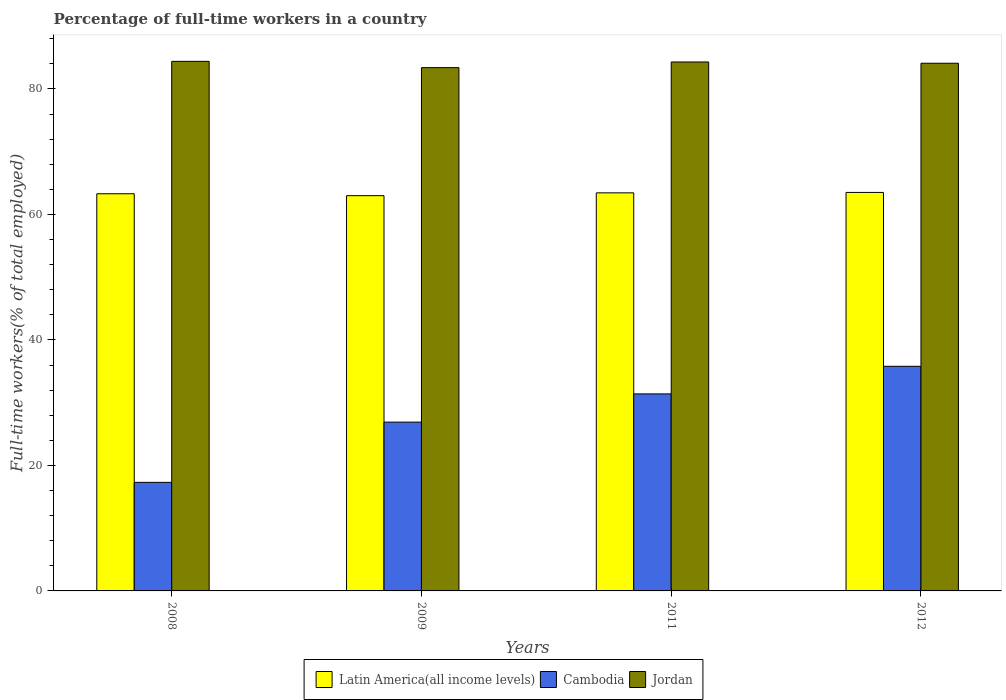How many different coloured bars are there?
Provide a short and direct response. 3. How many groups of bars are there?
Your response must be concise. 4. Are the number of bars on each tick of the X-axis equal?
Your answer should be compact. Yes. What is the percentage of full-time workers in Cambodia in 2009?
Your response must be concise. 26.9. Across all years, what is the maximum percentage of full-time workers in Cambodia?
Your answer should be compact. 35.8. Across all years, what is the minimum percentage of full-time workers in Cambodia?
Keep it short and to the point. 17.3. In which year was the percentage of full-time workers in Cambodia maximum?
Give a very brief answer. 2012. What is the total percentage of full-time workers in Jordan in the graph?
Provide a short and direct response. 336.2. What is the difference between the percentage of full-time workers in Latin America(all income levels) in 2008 and that in 2011?
Give a very brief answer. -0.14. What is the difference between the percentage of full-time workers in Cambodia in 2008 and the percentage of full-time workers in Jordan in 2012?
Your answer should be compact. -66.8. What is the average percentage of full-time workers in Cambodia per year?
Make the answer very short. 27.85. In the year 2009, what is the difference between the percentage of full-time workers in Cambodia and percentage of full-time workers in Latin America(all income levels)?
Make the answer very short. -36.09. In how many years, is the percentage of full-time workers in Jordan greater than 8 %?
Give a very brief answer. 4. What is the ratio of the percentage of full-time workers in Jordan in 2008 to that in 2009?
Your response must be concise. 1.01. Is the percentage of full-time workers in Jordan in 2008 less than that in 2009?
Your answer should be compact. No. What is the difference between the highest and the second highest percentage of full-time workers in Latin America(all income levels)?
Make the answer very short. 0.07. What is the difference between the highest and the lowest percentage of full-time workers in Cambodia?
Keep it short and to the point. 18.5. In how many years, is the percentage of full-time workers in Latin America(all income levels) greater than the average percentage of full-time workers in Latin America(all income levels) taken over all years?
Offer a very short reply. 2. Is the sum of the percentage of full-time workers in Jordan in 2009 and 2011 greater than the maximum percentage of full-time workers in Cambodia across all years?
Make the answer very short. Yes. What does the 1st bar from the left in 2012 represents?
Provide a short and direct response. Latin America(all income levels). What does the 1st bar from the right in 2008 represents?
Offer a very short reply. Jordan. How many bars are there?
Your answer should be compact. 12. Are all the bars in the graph horizontal?
Your answer should be compact. No. How many years are there in the graph?
Make the answer very short. 4. What is the difference between two consecutive major ticks on the Y-axis?
Your answer should be compact. 20. Are the values on the major ticks of Y-axis written in scientific E-notation?
Your answer should be very brief. No. Does the graph contain any zero values?
Offer a very short reply. No. Does the graph contain grids?
Provide a short and direct response. No. How many legend labels are there?
Provide a succinct answer. 3. What is the title of the graph?
Give a very brief answer. Percentage of full-time workers in a country. Does "Papua New Guinea" appear as one of the legend labels in the graph?
Keep it short and to the point. No. What is the label or title of the X-axis?
Offer a terse response. Years. What is the label or title of the Y-axis?
Provide a short and direct response. Full-time workers(% of total employed). What is the Full-time workers(% of total employed) of Latin America(all income levels) in 2008?
Offer a very short reply. 63.3. What is the Full-time workers(% of total employed) in Cambodia in 2008?
Your answer should be compact. 17.3. What is the Full-time workers(% of total employed) of Jordan in 2008?
Your response must be concise. 84.4. What is the Full-time workers(% of total employed) of Latin America(all income levels) in 2009?
Your response must be concise. 62.99. What is the Full-time workers(% of total employed) of Cambodia in 2009?
Ensure brevity in your answer.  26.9. What is the Full-time workers(% of total employed) in Jordan in 2009?
Provide a succinct answer. 83.4. What is the Full-time workers(% of total employed) of Latin America(all income levels) in 2011?
Ensure brevity in your answer.  63.44. What is the Full-time workers(% of total employed) in Cambodia in 2011?
Offer a terse response. 31.4. What is the Full-time workers(% of total employed) of Jordan in 2011?
Provide a short and direct response. 84.3. What is the Full-time workers(% of total employed) of Latin America(all income levels) in 2012?
Provide a succinct answer. 63.51. What is the Full-time workers(% of total employed) in Cambodia in 2012?
Offer a terse response. 35.8. What is the Full-time workers(% of total employed) in Jordan in 2012?
Provide a succinct answer. 84.1. Across all years, what is the maximum Full-time workers(% of total employed) in Latin America(all income levels)?
Give a very brief answer. 63.51. Across all years, what is the maximum Full-time workers(% of total employed) of Cambodia?
Your response must be concise. 35.8. Across all years, what is the maximum Full-time workers(% of total employed) in Jordan?
Make the answer very short. 84.4. Across all years, what is the minimum Full-time workers(% of total employed) in Latin America(all income levels)?
Offer a terse response. 62.99. Across all years, what is the minimum Full-time workers(% of total employed) of Cambodia?
Your answer should be compact. 17.3. Across all years, what is the minimum Full-time workers(% of total employed) in Jordan?
Your response must be concise. 83.4. What is the total Full-time workers(% of total employed) of Latin America(all income levels) in the graph?
Keep it short and to the point. 253.24. What is the total Full-time workers(% of total employed) in Cambodia in the graph?
Make the answer very short. 111.4. What is the total Full-time workers(% of total employed) in Jordan in the graph?
Make the answer very short. 336.2. What is the difference between the Full-time workers(% of total employed) in Latin America(all income levels) in 2008 and that in 2009?
Your answer should be compact. 0.3. What is the difference between the Full-time workers(% of total employed) in Jordan in 2008 and that in 2009?
Make the answer very short. 1. What is the difference between the Full-time workers(% of total employed) in Latin America(all income levels) in 2008 and that in 2011?
Your response must be concise. -0.14. What is the difference between the Full-time workers(% of total employed) of Cambodia in 2008 and that in 2011?
Keep it short and to the point. -14.1. What is the difference between the Full-time workers(% of total employed) of Jordan in 2008 and that in 2011?
Your answer should be compact. 0.1. What is the difference between the Full-time workers(% of total employed) in Latin America(all income levels) in 2008 and that in 2012?
Ensure brevity in your answer.  -0.21. What is the difference between the Full-time workers(% of total employed) in Cambodia in 2008 and that in 2012?
Provide a short and direct response. -18.5. What is the difference between the Full-time workers(% of total employed) in Latin America(all income levels) in 2009 and that in 2011?
Make the answer very short. -0.45. What is the difference between the Full-time workers(% of total employed) in Cambodia in 2009 and that in 2011?
Make the answer very short. -4.5. What is the difference between the Full-time workers(% of total employed) in Jordan in 2009 and that in 2011?
Your answer should be compact. -0.9. What is the difference between the Full-time workers(% of total employed) of Latin America(all income levels) in 2009 and that in 2012?
Make the answer very short. -0.52. What is the difference between the Full-time workers(% of total employed) of Cambodia in 2009 and that in 2012?
Ensure brevity in your answer.  -8.9. What is the difference between the Full-time workers(% of total employed) of Latin America(all income levels) in 2011 and that in 2012?
Give a very brief answer. -0.07. What is the difference between the Full-time workers(% of total employed) of Latin America(all income levels) in 2008 and the Full-time workers(% of total employed) of Cambodia in 2009?
Give a very brief answer. 36.4. What is the difference between the Full-time workers(% of total employed) in Latin America(all income levels) in 2008 and the Full-time workers(% of total employed) in Jordan in 2009?
Make the answer very short. -20.1. What is the difference between the Full-time workers(% of total employed) of Cambodia in 2008 and the Full-time workers(% of total employed) of Jordan in 2009?
Keep it short and to the point. -66.1. What is the difference between the Full-time workers(% of total employed) of Latin America(all income levels) in 2008 and the Full-time workers(% of total employed) of Cambodia in 2011?
Provide a succinct answer. 31.9. What is the difference between the Full-time workers(% of total employed) of Latin America(all income levels) in 2008 and the Full-time workers(% of total employed) of Jordan in 2011?
Your response must be concise. -21. What is the difference between the Full-time workers(% of total employed) of Cambodia in 2008 and the Full-time workers(% of total employed) of Jordan in 2011?
Your answer should be very brief. -67. What is the difference between the Full-time workers(% of total employed) of Latin America(all income levels) in 2008 and the Full-time workers(% of total employed) of Cambodia in 2012?
Give a very brief answer. 27.5. What is the difference between the Full-time workers(% of total employed) in Latin America(all income levels) in 2008 and the Full-time workers(% of total employed) in Jordan in 2012?
Provide a succinct answer. -20.8. What is the difference between the Full-time workers(% of total employed) of Cambodia in 2008 and the Full-time workers(% of total employed) of Jordan in 2012?
Make the answer very short. -66.8. What is the difference between the Full-time workers(% of total employed) in Latin America(all income levels) in 2009 and the Full-time workers(% of total employed) in Cambodia in 2011?
Provide a succinct answer. 31.59. What is the difference between the Full-time workers(% of total employed) of Latin America(all income levels) in 2009 and the Full-time workers(% of total employed) of Jordan in 2011?
Your response must be concise. -21.31. What is the difference between the Full-time workers(% of total employed) in Cambodia in 2009 and the Full-time workers(% of total employed) in Jordan in 2011?
Make the answer very short. -57.4. What is the difference between the Full-time workers(% of total employed) in Latin America(all income levels) in 2009 and the Full-time workers(% of total employed) in Cambodia in 2012?
Your answer should be compact. 27.19. What is the difference between the Full-time workers(% of total employed) in Latin America(all income levels) in 2009 and the Full-time workers(% of total employed) in Jordan in 2012?
Ensure brevity in your answer.  -21.11. What is the difference between the Full-time workers(% of total employed) in Cambodia in 2009 and the Full-time workers(% of total employed) in Jordan in 2012?
Give a very brief answer. -57.2. What is the difference between the Full-time workers(% of total employed) of Latin America(all income levels) in 2011 and the Full-time workers(% of total employed) of Cambodia in 2012?
Your answer should be very brief. 27.64. What is the difference between the Full-time workers(% of total employed) of Latin America(all income levels) in 2011 and the Full-time workers(% of total employed) of Jordan in 2012?
Provide a short and direct response. -20.66. What is the difference between the Full-time workers(% of total employed) of Cambodia in 2011 and the Full-time workers(% of total employed) of Jordan in 2012?
Offer a very short reply. -52.7. What is the average Full-time workers(% of total employed) of Latin America(all income levels) per year?
Your response must be concise. 63.31. What is the average Full-time workers(% of total employed) of Cambodia per year?
Your answer should be very brief. 27.85. What is the average Full-time workers(% of total employed) of Jordan per year?
Keep it short and to the point. 84.05. In the year 2008, what is the difference between the Full-time workers(% of total employed) in Latin America(all income levels) and Full-time workers(% of total employed) in Cambodia?
Your answer should be very brief. 46. In the year 2008, what is the difference between the Full-time workers(% of total employed) in Latin America(all income levels) and Full-time workers(% of total employed) in Jordan?
Your answer should be very brief. -21.1. In the year 2008, what is the difference between the Full-time workers(% of total employed) of Cambodia and Full-time workers(% of total employed) of Jordan?
Provide a short and direct response. -67.1. In the year 2009, what is the difference between the Full-time workers(% of total employed) of Latin America(all income levels) and Full-time workers(% of total employed) of Cambodia?
Provide a succinct answer. 36.09. In the year 2009, what is the difference between the Full-time workers(% of total employed) in Latin America(all income levels) and Full-time workers(% of total employed) in Jordan?
Give a very brief answer. -20.41. In the year 2009, what is the difference between the Full-time workers(% of total employed) in Cambodia and Full-time workers(% of total employed) in Jordan?
Your answer should be very brief. -56.5. In the year 2011, what is the difference between the Full-time workers(% of total employed) in Latin America(all income levels) and Full-time workers(% of total employed) in Cambodia?
Keep it short and to the point. 32.04. In the year 2011, what is the difference between the Full-time workers(% of total employed) in Latin America(all income levels) and Full-time workers(% of total employed) in Jordan?
Your answer should be compact. -20.86. In the year 2011, what is the difference between the Full-time workers(% of total employed) of Cambodia and Full-time workers(% of total employed) of Jordan?
Provide a short and direct response. -52.9. In the year 2012, what is the difference between the Full-time workers(% of total employed) in Latin America(all income levels) and Full-time workers(% of total employed) in Cambodia?
Offer a very short reply. 27.71. In the year 2012, what is the difference between the Full-time workers(% of total employed) of Latin America(all income levels) and Full-time workers(% of total employed) of Jordan?
Your answer should be compact. -20.59. In the year 2012, what is the difference between the Full-time workers(% of total employed) in Cambodia and Full-time workers(% of total employed) in Jordan?
Your answer should be compact. -48.3. What is the ratio of the Full-time workers(% of total employed) of Cambodia in 2008 to that in 2009?
Ensure brevity in your answer.  0.64. What is the ratio of the Full-time workers(% of total employed) of Jordan in 2008 to that in 2009?
Your answer should be compact. 1.01. What is the ratio of the Full-time workers(% of total employed) in Latin America(all income levels) in 2008 to that in 2011?
Ensure brevity in your answer.  1. What is the ratio of the Full-time workers(% of total employed) of Cambodia in 2008 to that in 2011?
Your answer should be very brief. 0.55. What is the ratio of the Full-time workers(% of total employed) in Cambodia in 2008 to that in 2012?
Your answer should be compact. 0.48. What is the ratio of the Full-time workers(% of total employed) of Cambodia in 2009 to that in 2011?
Your answer should be compact. 0.86. What is the ratio of the Full-time workers(% of total employed) of Jordan in 2009 to that in 2011?
Your answer should be compact. 0.99. What is the ratio of the Full-time workers(% of total employed) in Cambodia in 2009 to that in 2012?
Ensure brevity in your answer.  0.75. What is the ratio of the Full-time workers(% of total employed) in Latin America(all income levels) in 2011 to that in 2012?
Make the answer very short. 1. What is the ratio of the Full-time workers(% of total employed) of Cambodia in 2011 to that in 2012?
Your response must be concise. 0.88. What is the ratio of the Full-time workers(% of total employed) in Jordan in 2011 to that in 2012?
Offer a very short reply. 1. What is the difference between the highest and the second highest Full-time workers(% of total employed) in Latin America(all income levels)?
Keep it short and to the point. 0.07. What is the difference between the highest and the second highest Full-time workers(% of total employed) in Cambodia?
Provide a succinct answer. 4.4. What is the difference between the highest and the lowest Full-time workers(% of total employed) in Latin America(all income levels)?
Offer a terse response. 0.52. 